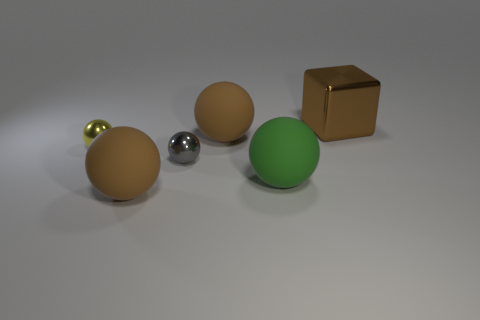Subtract all green spheres. How many spheres are left? 4 Subtract all big green balls. How many balls are left? 4 Subtract all purple spheres. Subtract all brown blocks. How many spheres are left? 5 Add 4 small red balls. How many objects exist? 10 Subtract all spheres. How many objects are left? 1 Subtract all tiny gray metal things. Subtract all green objects. How many objects are left? 4 Add 2 blocks. How many blocks are left? 3 Add 2 small balls. How many small balls exist? 4 Subtract 0 green cylinders. How many objects are left? 6 